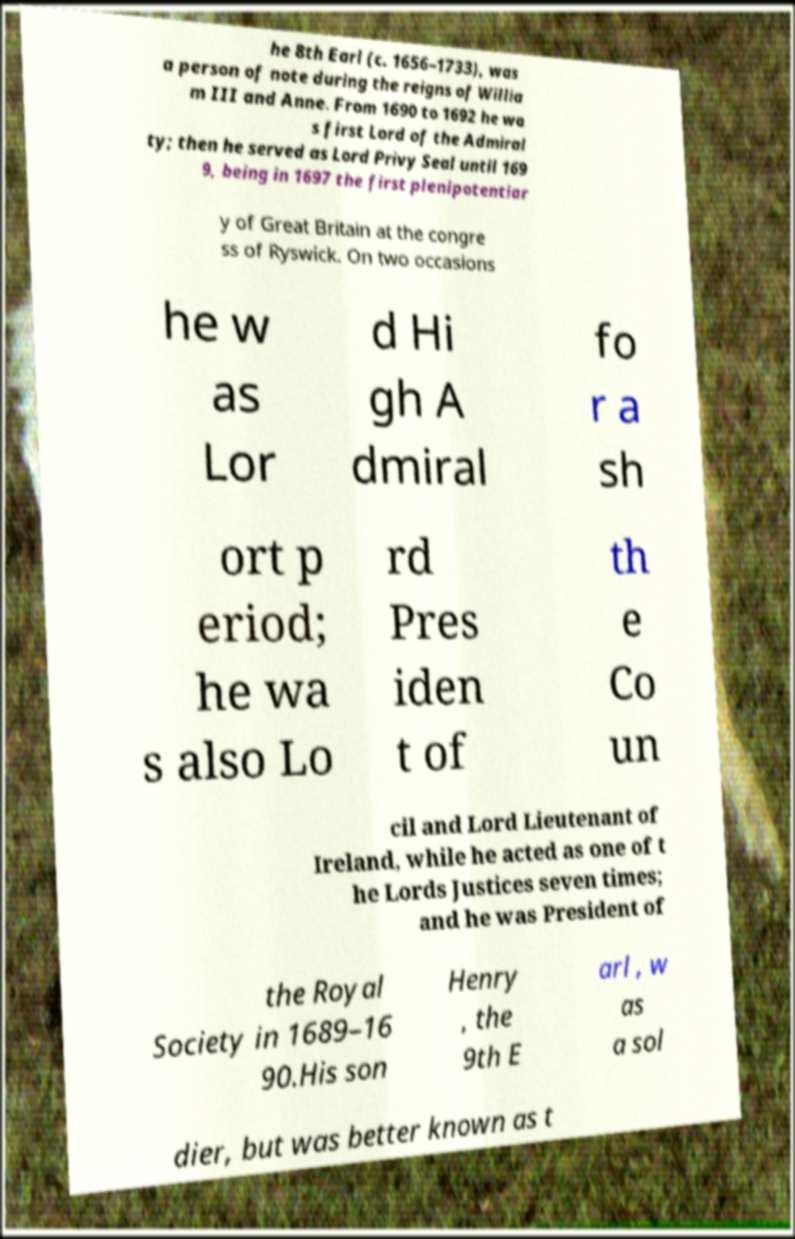There's text embedded in this image that I need extracted. Can you transcribe it verbatim? he 8th Earl (c. 1656–1733), was a person of note during the reigns of Willia m III and Anne. From 1690 to 1692 he wa s first Lord of the Admiral ty; then he served as Lord Privy Seal until 169 9, being in 1697 the first plenipotentiar y of Great Britain at the congre ss of Ryswick. On two occasions he w as Lor d Hi gh A dmiral fo r a sh ort p eriod; he wa s also Lo rd Pres iden t of th e Co un cil and Lord Lieutenant of Ireland, while he acted as one of t he Lords Justices seven times; and he was President of the Royal Society in 1689–16 90.His son Henry , the 9th E arl , w as a sol dier, but was better known as t 